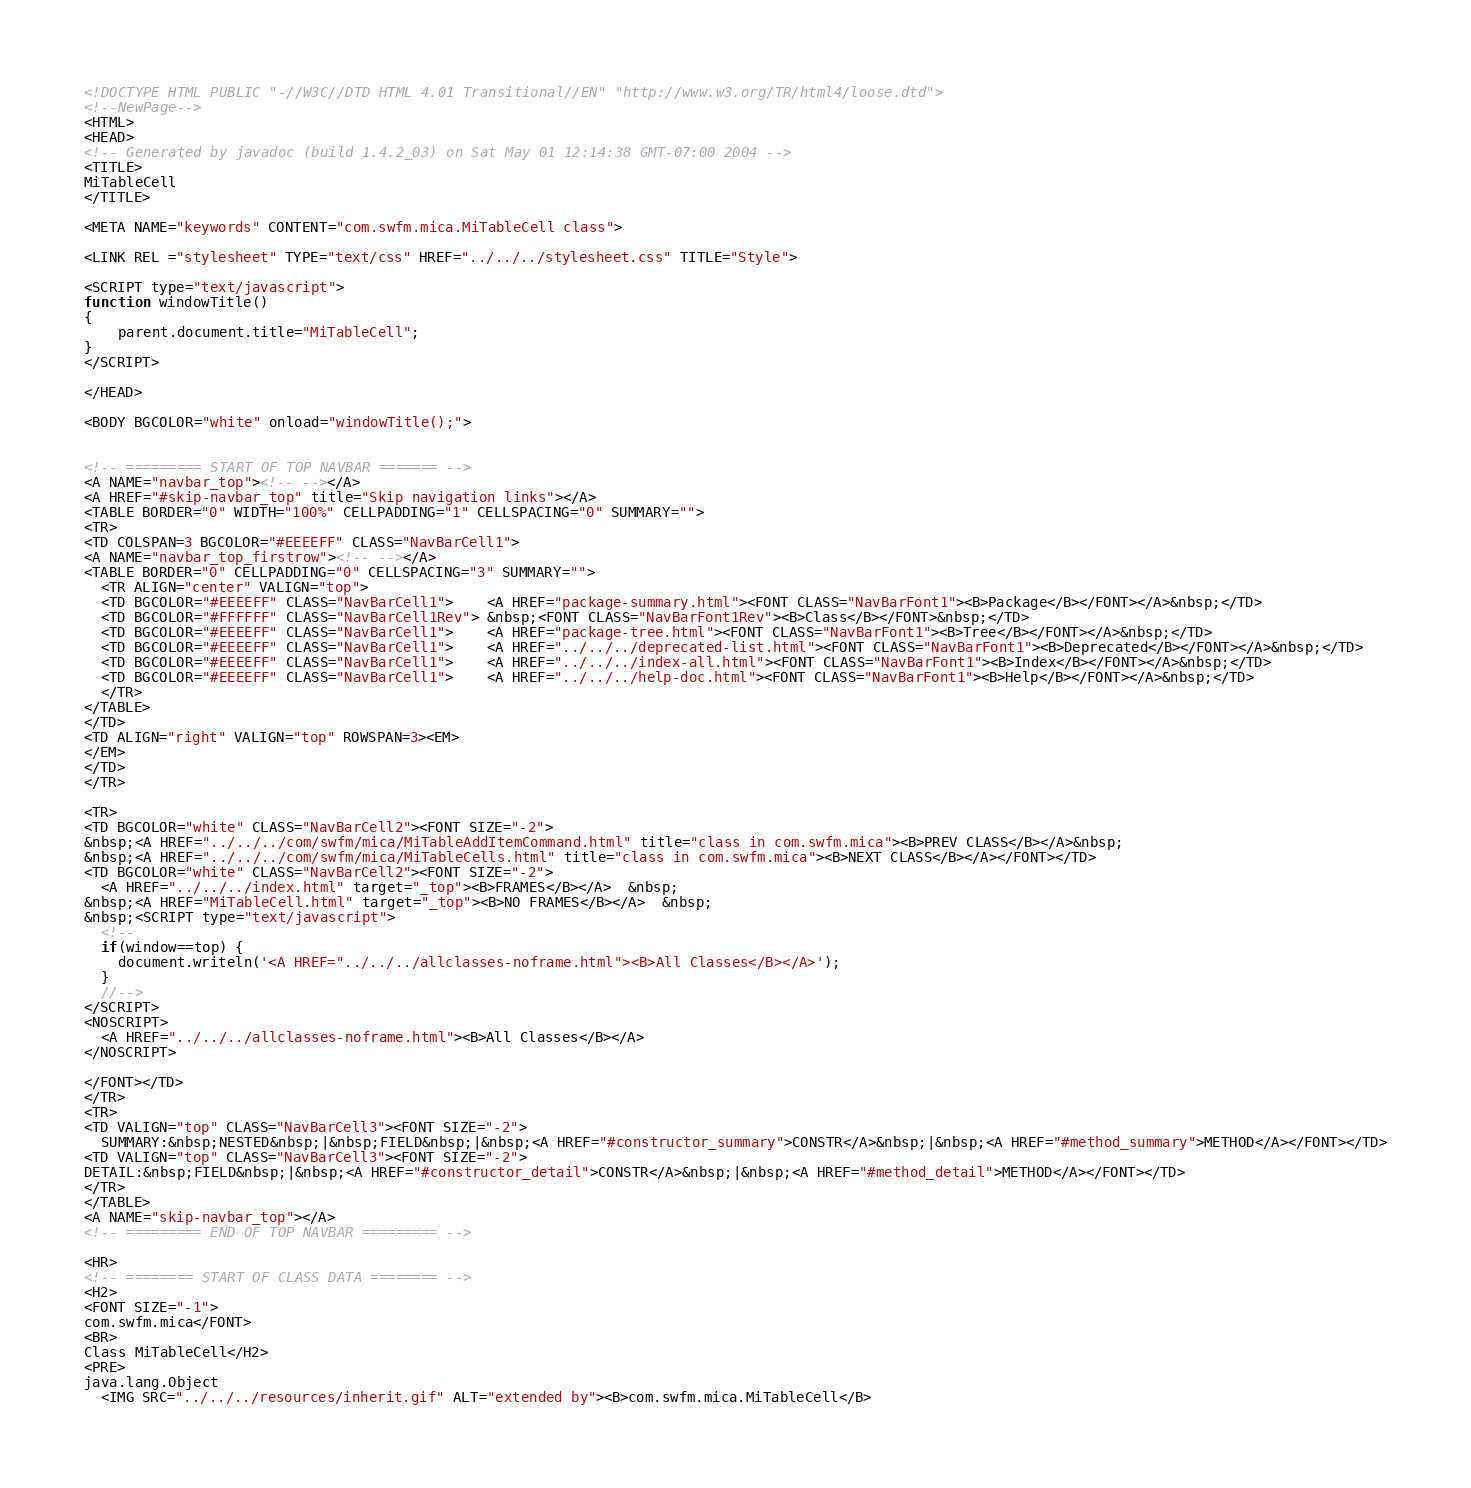Convert code to text. <code><loc_0><loc_0><loc_500><loc_500><_HTML_><!DOCTYPE HTML PUBLIC "-//W3C//DTD HTML 4.01 Transitional//EN" "http://www.w3.org/TR/html4/loose.dtd">
<!--NewPage-->
<HTML>
<HEAD>
<!-- Generated by javadoc (build 1.4.2_03) on Sat May 01 12:14:38 GMT-07:00 2004 -->
<TITLE>
MiTableCell
</TITLE>

<META NAME="keywords" CONTENT="com.swfm.mica.MiTableCell class">

<LINK REL ="stylesheet" TYPE="text/css" HREF="../../../stylesheet.css" TITLE="Style">

<SCRIPT type="text/javascript">
function windowTitle()
{
    parent.document.title="MiTableCell";
}
</SCRIPT>

</HEAD>

<BODY BGCOLOR="white" onload="windowTitle();">


<!-- ========= START OF TOP NAVBAR ======= -->
<A NAME="navbar_top"><!-- --></A>
<A HREF="#skip-navbar_top" title="Skip navigation links"></A>
<TABLE BORDER="0" WIDTH="100%" CELLPADDING="1" CELLSPACING="0" SUMMARY="">
<TR>
<TD COLSPAN=3 BGCOLOR="#EEEEFF" CLASS="NavBarCell1">
<A NAME="navbar_top_firstrow"><!-- --></A>
<TABLE BORDER="0" CELLPADDING="0" CELLSPACING="3" SUMMARY="">
  <TR ALIGN="center" VALIGN="top">
  <TD BGCOLOR="#EEEEFF" CLASS="NavBarCell1">    <A HREF="package-summary.html"><FONT CLASS="NavBarFont1"><B>Package</B></FONT></A>&nbsp;</TD>
  <TD BGCOLOR="#FFFFFF" CLASS="NavBarCell1Rev"> &nbsp;<FONT CLASS="NavBarFont1Rev"><B>Class</B></FONT>&nbsp;</TD>
  <TD BGCOLOR="#EEEEFF" CLASS="NavBarCell1">    <A HREF="package-tree.html"><FONT CLASS="NavBarFont1"><B>Tree</B></FONT></A>&nbsp;</TD>
  <TD BGCOLOR="#EEEEFF" CLASS="NavBarCell1">    <A HREF="../../../deprecated-list.html"><FONT CLASS="NavBarFont1"><B>Deprecated</B></FONT></A>&nbsp;</TD>
  <TD BGCOLOR="#EEEEFF" CLASS="NavBarCell1">    <A HREF="../../../index-all.html"><FONT CLASS="NavBarFont1"><B>Index</B></FONT></A>&nbsp;</TD>
  <TD BGCOLOR="#EEEEFF" CLASS="NavBarCell1">    <A HREF="../../../help-doc.html"><FONT CLASS="NavBarFont1"><B>Help</B></FONT></A>&nbsp;</TD>
  </TR>
</TABLE>
</TD>
<TD ALIGN="right" VALIGN="top" ROWSPAN=3><EM>
</EM>
</TD>
</TR>

<TR>
<TD BGCOLOR="white" CLASS="NavBarCell2"><FONT SIZE="-2">
&nbsp;<A HREF="../../../com/swfm/mica/MiTableAddItemCommand.html" title="class in com.swfm.mica"><B>PREV CLASS</B></A>&nbsp;
&nbsp;<A HREF="../../../com/swfm/mica/MiTableCells.html" title="class in com.swfm.mica"><B>NEXT CLASS</B></A></FONT></TD>
<TD BGCOLOR="white" CLASS="NavBarCell2"><FONT SIZE="-2">
  <A HREF="../../../index.html" target="_top"><B>FRAMES</B></A>  &nbsp;
&nbsp;<A HREF="MiTableCell.html" target="_top"><B>NO FRAMES</B></A>  &nbsp;
&nbsp;<SCRIPT type="text/javascript">
  <!--
  if(window==top) {
    document.writeln('<A HREF="../../../allclasses-noframe.html"><B>All Classes</B></A>');
  }
  //-->
</SCRIPT>
<NOSCRIPT>
  <A HREF="../../../allclasses-noframe.html"><B>All Classes</B></A>
</NOSCRIPT>

</FONT></TD>
</TR>
<TR>
<TD VALIGN="top" CLASS="NavBarCell3"><FONT SIZE="-2">
  SUMMARY:&nbsp;NESTED&nbsp;|&nbsp;FIELD&nbsp;|&nbsp;<A HREF="#constructor_summary">CONSTR</A>&nbsp;|&nbsp;<A HREF="#method_summary">METHOD</A></FONT></TD>
<TD VALIGN="top" CLASS="NavBarCell3"><FONT SIZE="-2">
DETAIL:&nbsp;FIELD&nbsp;|&nbsp;<A HREF="#constructor_detail">CONSTR</A>&nbsp;|&nbsp;<A HREF="#method_detail">METHOD</A></FONT></TD>
</TR>
</TABLE>
<A NAME="skip-navbar_top"></A>
<!-- ========= END OF TOP NAVBAR ========= -->

<HR>
<!-- ======== START OF CLASS DATA ======== -->
<H2>
<FONT SIZE="-1">
com.swfm.mica</FONT>
<BR>
Class MiTableCell</H2>
<PRE>
java.lang.Object
  <IMG SRC="../../../resources/inherit.gif" ALT="extended by"><B>com.swfm.mica.MiTableCell</B></code> 